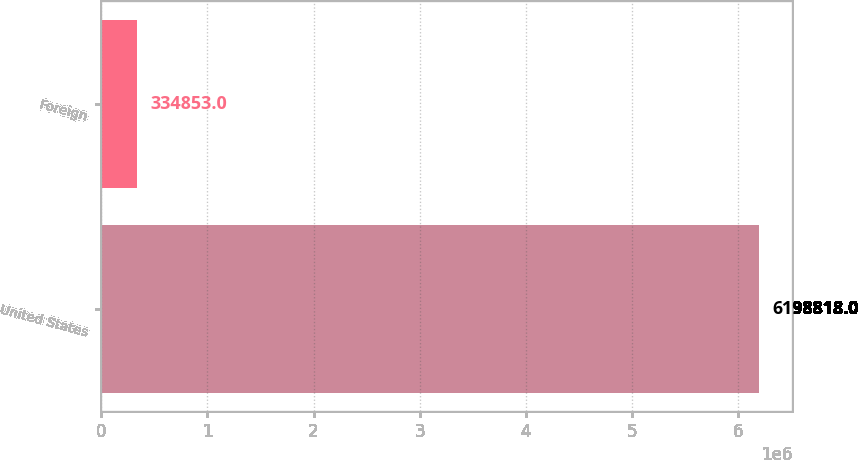Convert chart to OTSL. <chart><loc_0><loc_0><loc_500><loc_500><bar_chart><fcel>United States<fcel>Foreign<nl><fcel>6.19882e+06<fcel>334853<nl></chart> 